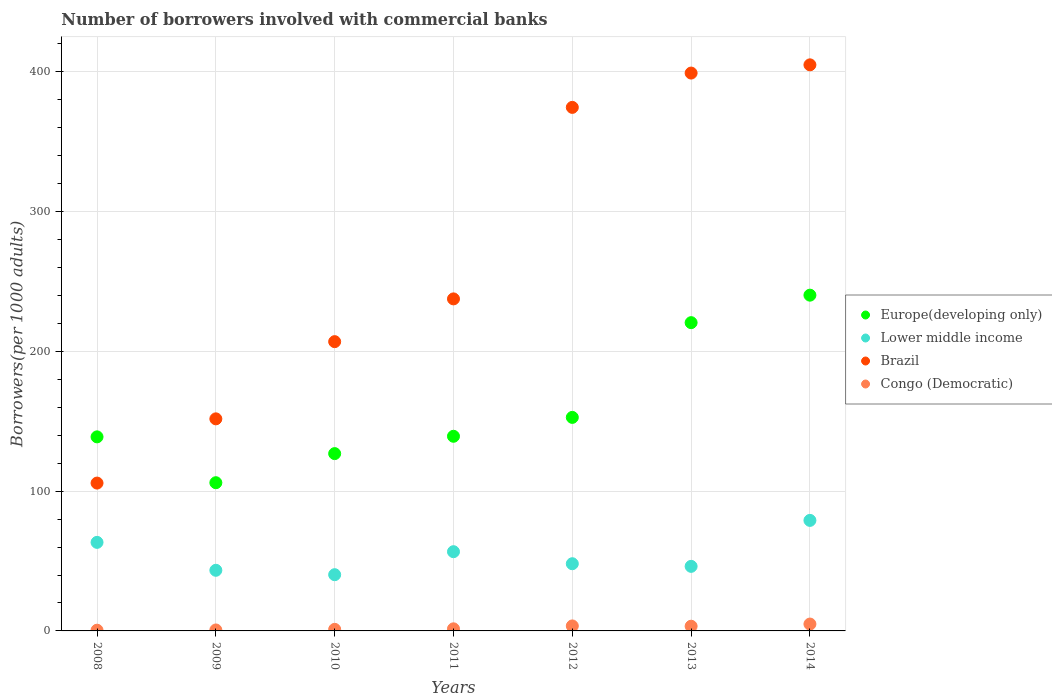Is the number of dotlines equal to the number of legend labels?
Your answer should be very brief. Yes. What is the number of borrowers involved with commercial banks in Europe(developing only) in 2010?
Offer a terse response. 126.87. Across all years, what is the maximum number of borrowers involved with commercial banks in Lower middle income?
Offer a terse response. 79.08. Across all years, what is the minimum number of borrowers involved with commercial banks in Europe(developing only)?
Provide a short and direct response. 106.05. In which year was the number of borrowers involved with commercial banks in Lower middle income minimum?
Give a very brief answer. 2010. What is the total number of borrowers involved with commercial banks in Brazil in the graph?
Provide a short and direct response. 1880.83. What is the difference between the number of borrowers involved with commercial banks in Lower middle income in 2008 and that in 2009?
Give a very brief answer. 19.98. What is the difference between the number of borrowers involved with commercial banks in Europe(developing only) in 2008 and the number of borrowers involved with commercial banks in Lower middle income in 2009?
Your answer should be very brief. 95.47. What is the average number of borrowers involved with commercial banks in Congo (Democratic) per year?
Offer a terse response. 2.24. In the year 2009, what is the difference between the number of borrowers involved with commercial banks in Lower middle income and number of borrowers involved with commercial banks in Europe(developing only)?
Offer a very short reply. -62.67. In how many years, is the number of borrowers involved with commercial banks in Europe(developing only) greater than 180?
Your response must be concise. 2. What is the ratio of the number of borrowers involved with commercial banks in Lower middle income in 2012 to that in 2014?
Your response must be concise. 0.61. Is the number of borrowers involved with commercial banks in Brazil in 2012 less than that in 2013?
Ensure brevity in your answer.  Yes. What is the difference between the highest and the second highest number of borrowers involved with commercial banks in Congo (Democratic)?
Your answer should be very brief. 1.34. What is the difference between the highest and the lowest number of borrowers involved with commercial banks in Congo (Democratic)?
Make the answer very short. 4.39. Is the sum of the number of borrowers involved with commercial banks in Congo (Democratic) in 2008 and 2012 greater than the maximum number of borrowers involved with commercial banks in Europe(developing only) across all years?
Offer a very short reply. No. Is it the case that in every year, the sum of the number of borrowers involved with commercial banks in Lower middle income and number of borrowers involved with commercial banks in Congo (Democratic)  is greater than the number of borrowers involved with commercial banks in Europe(developing only)?
Keep it short and to the point. No. Does the number of borrowers involved with commercial banks in Brazil monotonically increase over the years?
Your answer should be compact. Yes. Is the number of borrowers involved with commercial banks in Congo (Democratic) strictly less than the number of borrowers involved with commercial banks in Brazil over the years?
Provide a succinct answer. Yes. How many dotlines are there?
Offer a terse response. 4. Are the values on the major ticks of Y-axis written in scientific E-notation?
Your answer should be very brief. No. Does the graph contain any zero values?
Your response must be concise. No. Does the graph contain grids?
Provide a succinct answer. Yes. Where does the legend appear in the graph?
Your response must be concise. Center right. How many legend labels are there?
Give a very brief answer. 4. How are the legend labels stacked?
Your answer should be very brief. Vertical. What is the title of the graph?
Ensure brevity in your answer.  Number of borrowers involved with commercial banks. Does "Sao Tome and Principe" appear as one of the legend labels in the graph?
Your answer should be very brief. No. What is the label or title of the Y-axis?
Give a very brief answer. Borrowers(per 1000 adults). What is the Borrowers(per 1000 adults) of Europe(developing only) in 2008?
Give a very brief answer. 138.85. What is the Borrowers(per 1000 adults) of Lower middle income in 2008?
Offer a very short reply. 63.36. What is the Borrowers(per 1000 adults) in Brazil in 2008?
Offer a very short reply. 105.78. What is the Borrowers(per 1000 adults) of Congo (Democratic) in 2008?
Your response must be concise. 0.52. What is the Borrowers(per 1000 adults) in Europe(developing only) in 2009?
Your answer should be very brief. 106.05. What is the Borrowers(per 1000 adults) of Lower middle income in 2009?
Give a very brief answer. 43.38. What is the Borrowers(per 1000 adults) in Brazil in 2009?
Provide a short and direct response. 151.74. What is the Borrowers(per 1000 adults) of Congo (Democratic) in 2009?
Provide a succinct answer. 0.68. What is the Borrowers(per 1000 adults) in Europe(developing only) in 2010?
Provide a short and direct response. 126.87. What is the Borrowers(per 1000 adults) in Lower middle income in 2010?
Your response must be concise. 40.23. What is the Borrowers(per 1000 adults) in Brazil in 2010?
Provide a succinct answer. 206.97. What is the Borrowers(per 1000 adults) of Congo (Democratic) in 2010?
Provide a short and direct response. 1.12. What is the Borrowers(per 1000 adults) of Europe(developing only) in 2011?
Offer a terse response. 139.27. What is the Borrowers(per 1000 adults) of Lower middle income in 2011?
Ensure brevity in your answer.  56.68. What is the Borrowers(per 1000 adults) of Brazil in 2011?
Offer a very short reply. 237.57. What is the Borrowers(per 1000 adults) in Congo (Democratic) in 2011?
Your answer should be very brief. 1.5. What is the Borrowers(per 1000 adults) in Europe(developing only) in 2012?
Your answer should be very brief. 152.78. What is the Borrowers(per 1000 adults) in Lower middle income in 2012?
Give a very brief answer. 48.08. What is the Borrowers(per 1000 adults) of Brazil in 2012?
Your answer should be compact. 374.59. What is the Borrowers(per 1000 adults) in Congo (Democratic) in 2012?
Give a very brief answer. 3.57. What is the Borrowers(per 1000 adults) in Europe(developing only) in 2013?
Your answer should be very brief. 220.56. What is the Borrowers(per 1000 adults) in Lower middle income in 2013?
Ensure brevity in your answer.  46.19. What is the Borrowers(per 1000 adults) of Brazil in 2013?
Offer a very short reply. 399.14. What is the Borrowers(per 1000 adults) in Congo (Democratic) in 2013?
Make the answer very short. 3.36. What is the Borrowers(per 1000 adults) in Europe(developing only) in 2014?
Your answer should be very brief. 240.23. What is the Borrowers(per 1000 adults) in Lower middle income in 2014?
Keep it short and to the point. 79.08. What is the Borrowers(per 1000 adults) in Brazil in 2014?
Your answer should be very brief. 405.03. What is the Borrowers(per 1000 adults) in Congo (Democratic) in 2014?
Offer a terse response. 4.91. Across all years, what is the maximum Borrowers(per 1000 adults) of Europe(developing only)?
Your answer should be very brief. 240.23. Across all years, what is the maximum Borrowers(per 1000 adults) of Lower middle income?
Provide a short and direct response. 79.08. Across all years, what is the maximum Borrowers(per 1000 adults) of Brazil?
Your response must be concise. 405.03. Across all years, what is the maximum Borrowers(per 1000 adults) in Congo (Democratic)?
Your answer should be very brief. 4.91. Across all years, what is the minimum Borrowers(per 1000 adults) in Europe(developing only)?
Provide a succinct answer. 106.05. Across all years, what is the minimum Borrowers(per 1000 adults) in Lower middle income?
Offer a terse response. 40.23. Across all years, what is the minimum Borrowers(per 1000 adults) in Brazil?
Give a very brief answer. 105.78. Across all years, what is the minimum Borrowers(per 1000 adults) in Congo (Democratic)?
Your answer should be very brief. 0.52. What is the total Borrowers(per 1000 adults) in Europe(developing only) in the graph?
Offer a very short reply. 1124.6. What is the total Borrowers(per 1000 adults) in Lower middle income in the graph?
Keep it short and to the point. 377. What is the total Borrowers(per 1000 adults) in Brazil in the graph?
Give a very brief answer. 1880.83. What is the total Borrowers(per 1000 adults) in Congo (Democratic) in the graph?
Provide a short and direct response. 15.67. What is the difference between the Borrowers(per 1000 adults) of Europe(developing only) in 2008 and that in 2009?
Keep it short and to the point. 32.8. What is the difference between the Borrowers(per 1000 adults) in Lower middle income in 2008 and that in 2009?
Ensure brevity in your answer.  19.98. What is the difference between the Borrowers(per 1000 adults) in Brazil in 2008 and that in 2009?
Keep it short and to the point. -45.96. What is the difference between the Borrowers(per 1000 adults) in Congo (Democratic) in 2008 and that in 2009?
Offer a very short reply. -0.16. What is the difference between the Borrowers(per 1000 adults) of Europe(developing only) in 2008 and that in 2010?
Provide a short and direct response. 11.98. What is the difference between the Borrowers(per 1000 adults) in Lower middle income in 2008 and that in 2010?
Your answer should be very brief. 23.13. What is the difference between the Borrowers(per 1000 adults) of Brazil in 2008 and that in 2010?
Your response must be concise. -101.2. What is the difference between the Borrowers(per 1000 adults) in Congo (Democratic) in 2008 and that in 2010?
Keep it short and to the point. -0.61. What is the difference between the Borrowers(per 1000 adults) of Europe(developing only) in 2008 and that in 2011?
Provide a succinct answer. -0.42. What is the difference between the Borrowers(per 1000 adults) of Lower middle income in 2008 and that in 2011?
Your answer should be very brief. 6.67. What is the difference between the Borrowers(per 1000 adults) of Brazil in 2008 and that in 2011?
Offer a very short reply. -131.79. What is the difference between the Borrowers(per 1000 adults) of Congo (Democratic) in 2008 and that in 2011?
Your answer should be compact. -0.98. What is the difference between the Borrowers(per 1000 adults) of Europe(developing only) in 2008 and that in 2012?
Your answer should be compact. -13.93. What is the difference between the Borrowers(per 1000 adults) in Lower middle income in 2008 and that in 2012?
Keep it short and to the point. 15.28. What is the difference between the Borrowers(per 1000 adults) of Brazil in 2008 and that in 2012?
Offer a terse response. -268.82. What is the difference between the Borrowers(per 1000 adults) in Congo (Democratic) in 2008 and that in 2012?
Give a very brief answer. -3.05. What is the difference between the Borrowers(per 1000 adults) in Europe(developing only) in 2008 and that in 2013?
Make the answer very short. -81.71. What is the difference between the Borrowers(per 1000 adults) in Lower middle income in 2008 and that in 2013?
Make the answer very short. 17.17. What is the difference between the Borrowers(per 1000 adults) in Brazil in 2008 and that in 2013?
Your answer should be compact. -293.36. What is the difference between the Borrowers(per 1000 adults) of Congo (Democratic) in 2008 and that in 2013?
Ensure brevity in your answer.  -2.84. What is the difference between the Borrowers(per 1000 adults) in Europe(developing only) in 2008 and that in 2014?
Provide a short and direct response. -101.38. What is the difference between the Borrowers(per 1000 adults) in Lower middle income in 2008 and that in 2014?
Ensure brevity in your answer.  -15.72. What is the difference between the Borrowers(per 1000 adults) in Brazil in 2008 and that in 2014?
Your answer should be compact. -299.25. What is the difference between the Borrowers(per 1000 adults) of Congo (Democratic) in 2008 and that in 2014?
Provide a short and direct response. -4.39. What is the difference between the Borrowers(per 1000 adults) of Europe(developing only) in 2009 and that in 2010?
Keep it short and to the point. -20.82. What is the difference between the Borrowers(per 1000 adults) in Lower middle income in 2009 and that in 2010?
Provide a succinct answer. 3.15. What is the difference between the Borrowers(per 1000 adults) of Brazil in 2009 and that in 2010?
Your answer should be very brief. -55.23. What is the difference between the Borrowers(per 1000 adults) of Congo (Democratic) in 2009 and that in 2010?
Offer a very short reply. -0.44. What is the difference between the Borrowers(per 1000 adults) in Europe(developing only) in 2009 and that in 2011?
Provide a short and direct response. -33.22. What is the difference between the Borrowers(per 1000 adults) of Lower middle income in 2009 and that in 2011?
Keep it short and to the point. -13.31. What is the difference between the Borrowers(per 1000 adults) of Brazil in 2009 and that in 2011?
Ensure brevity in your answer.  -85.83. What is the difference between the Borrowers(per 1000 adults) of Congo (Democratic) in 2009 and that in 2011?
Provide a short and direct response. -0.82. What is the difference between the Borrowers(per 1000 adults) in Europe(developing only) in 2009 and that in 2012?
Keep it short and to the point. -46.73. What is the difference between the Borrowers(per 1000 adults) of Lower middle income in 2009 and that in 2012?
Your answer should be very brief. -4.7. What is the difference between the Borrowers(per 1000 adults) in Brazil in 2009 and that in 2012?
Keep it short and to the point. -222.85. What is the difference between the Borrowers(per 1000 adults) in Congo (Democratic) in 2009 and that in 2012?
Provide a succinct answer. -2.89. What is the difference between the Borrowers(per 1000 adults) of Europe(developing only) in 2009 and that in 2013?
Keep it short and to the point. -114.52. What is the difference between the Borrowers(per 1000 adults) of Lower middle income in 2009 and that in 2013?
Your answer should be very brief. -2.81. What is the difference between the Borrowers(per 1000 adults) in Brazil in 2009 and that in 2013?
Your response must be concise. -247.4. What is the difference between the Borrowers(per 1000 adults) of Congo (Democratic) in 2009 and that in 2013?
Provide a succinct answer. -2.68. What is the difference between the Borrowers(per 1000 adults) of Europe(developing only) in 2009 and that in 2014?
Offer a very short reply. -134.19. What is the difference between the Borrowers(per 1000 adults) in Lower middle income in 2009 and that in 2014?
Offer a very short reply. -35.7. What is the difference between the Borrowers(per 1000 adults) in Brazil in 2009 and that in 2014?
Keep it short and to the point. -253.29. What is the difference between the Borrowers(per 1000 adults) in Congo (Democratic) in 2009 and that in 2014?
Ensure brevity in your answer.  -4.23. What is the difference between the Borrowers(per 1000 adults) of Europe(developing only) in 2010 and that in 2011?
Offer a terse response. -12.4. What is the difference between the Borrowers(per 1000 adults) in Lower middle income in 2010 and that in 2011?
Offer a terse response. -16.45. What is the difference between the Borrowers(per 1000 adults) in Brazil in 2010 and that in 2011?
Make the answer very short. -30.59. What is the difference between the Borrowers(per 1000 adults) of Congo (Democratic) in 2010 and that in 2011?
Ensure brevity in your answer.  -0.38. What is the difference between the Borrowers(per 1000 adults) of Europe(developing only) in 2010 and that in 2012?
Your answer should be compact. -25.91. What is the difference between the Borrowers(per 1000 adults) of Lower middle income in 2010 and that in 2012?
Your answer should be very brief. -7.85. What is the difference between the Borrowers(per 1000 adults) of Brazil in 2010 and that in 2012?
Your answer should be compact. -167.62. What is the difference between the Borrowers(per 1000 adults) of Congo (Democratic) in 2010 and that in 2012?
Provide a short and direct response. -2.45. What is the difference between the Borrowers(per 1000 adults) in Europe(developing only) in 2010 and that in 2013?
Your answer should be very brief. -93.7. What is the difference between the Borrowers(per 1000 adults) in Lower middle income in 2010 and that in 2013?
Ensure brevity in your answer.  -5.96. What is the difference between the Borrowers(per 1000 adults) in Brazil in 2010 and that in 2013?
Your answer should be very brief. -192.17. What is the difference between the Borrowers(per 1000 adults) of Congo (Democratic) in 2010 and that in 2013?
Give a very brief answer. -2.24. What is the difference between the Borrowers(per 1000 adults) of Europe(developing only) in 2010 and that in 2014?
Provide a short and direct response. -113.37. What is the difference between the Borrowers(per 1000 adults) of Lower middle income in 2010 and that in 2014?
Keep it short and to the point. -38.85. What is the difference between the Borrowers(per 1000 adults) in Brazil in 2010 and that in 2014?
Ensure brevity in your answer.  -198.06. What is the difference between the Borrowers(per 1000 adults) of Congo (Democratic) in 2010 and that in 2014?
Give a very brief answer. -3.79. What is the difference between the Borrowers(per 1000 adults) of Europe(developing only) in 2011 and that in 2012?
Ensure brevity in your answer.  -13.51. What is the difference between the Borrowers(per 1000 adults) of Lower middle income in 2011 and that in 2012?
Provide a short and direct response. 8.61. What is the difference between the Borrowers(per 1000 adults) in Brazil in 2011 and that in 2012?
Give a very brief answer. -137.03. What is the difference between the Borrowers(per 1000 adults) of Congo (Democratic) in 2011 and that in 2012?
Give a very brief answer. -2.07. What is the difference between the Borrowers(per 1000 adults) of Europe(developing only) in 2011 and that in 2013?
Provide a succinct answer. -81.3. What is the difference between the Borrowers(per 1000 adults) in Lower middle income in 2011 and that in 2013?
Make the answer very short. 10.49. What is the difference between the Borrowers(per 1000 adults) in Brazil in 2011 and that in 2013?
Keep it short and to the point. -161.57. What is the difference between the Borrowers(per 1000 adults) in Congo (Democratic) in 2011 and that in 2013?
Keep it short and to the point. -1.86. What is the difference between the Borrowers(per 1000 adults) in Europe(developing only) in 2011 and that in 2014?
Keep it short and to the point. -100.97. What is the difference between the Borrowers(per 1000 adults) in Lower middle income in 2011 and that in 2014?
Give a very brief answer. -22.4. What is the difference between the Borrowers(per 1000 adults) in Brazil in 2011 and that in 2014?
Provide a succinct answer. -167.46. What is the difference between the Borrowers(per 1000 adults) of Congo (Democratic) in 2011 and that in 2014?
Ensure brevity in your answer.  -3.41. What is the difference between the Borrowers(per 1000 adults) of Europe(developing only) in 2012 and that in 2013?
Keep it short and to the point. -67.78. What is the difference between the Borrowers(per 1000 adults) of Lower middle income in 2012 and that in 2013?
Your answer should be compact. 1.89. What is the difference between the Borrowers(per 1000 adults) of Brazil in 2012 and that in 2013?
Offer a terse response. -24.55. What is the difference between the Borrowers(per 1000 adults) of Congo (Democratic) in 2012 and that in 2013?
Give a very brief answer. 0.21. What is the difference between the Borrowers(per 1000 adults) of Europe(developing only) in 2012 and that in 2014?
Ensure brevity in your answer.  -87.45. What is the difference between the Borrowers(per 1000 adults) in Lower middle income in 2012 and that in 2014?
Make the answer very short. -31. What is the difference between the Borrowers(per 1000 adults) in Brazil in 2012 and that in 2014?
Provide a succinct answer. -30.44. What is the difference between the Borrowers(per 1000 adults) of Congo (Democratic) in 2012 and that in 2014?
Your answer should be compact. -1.34. What is the difference between the Borrowers(per 1000 adults) of Europe(developing only) in 2013 and that in 2014?
Offer a very short reply. -19.67. What is the difference between the Borrowers(per 1000 adults) in Lower middle income in 2013 and that in 2014?
Give a very brief answer. -32.89. What is the difference between the Borrowers(per 1000 adults) of Brazil in 2013 and that in 2014?
Offer a terse response. -5.89. What is the difference between the Borrowers(per 1000 adults) of Congo (Democratic) in 2013 and that in 2014?
Offer a very short reply. -1.55. What is the difference between the Borrowers(per 1000 adults) in Europe(developing only) in 2008 and the Borrowers(per 1000 adults) in Lower middle income in 2009?
Make the answer very short. 95.47. What is the difference between the Borrowers(per 1000 adults) in Europe(developing only) in 2008 and the Borrowers(per 1000 adults) in Brazil in 2009?
Provide a succinct answer. -12.89. What is the difference between the Borrowers(per 1000 adults) in Europe(developing only) in 2008 and the Borrowers(per 1000 adults) in Congo (Democratic) in 2009?
Ensure brevity in your answer.  138.17. What is the difference between the Borrowers(per 1000 adults) of Lower middle income in 2008 and the Borrowers(per 1000 adults) of Brazil in 2009?
Provide a succinct answer. -88.38. What is the difference between the Borrowers(per 1000 adults) in Lower middle income in 2008 and the Borrowers(per 1000 adults) in Congo (Democratic) in 2009?
Your answer should be very brief. 62.67. What is the difference between the Borrowers(per 1000 adults) in Brazil in 2008 and the Borrowers(per 1000 adults) in Congo (Democratic) in 2009?
Give a very brief answer. 105.09. What is the difference between the Borrowers(per 1000 adults) of Europe(developing only) in 2008 and the Borrowers(per 1000 adults) of Lower middle income in 2010?
Your answer should be very brief. 98.62. What is the difference between the Borrowers(per 1000 adults) of Europe(developing only) in 2008 and the Borrowers(per 1000 adults) of Brazil in 2010?
Make the answer very short. -68.13. What is the difference between the Borrowers(per 1000 adults) in Europe(developing only) in 2008 and the Borrowers(per 1000 adults) in Congo (Democratic) in 2010?
Make the answer very short. 137.72. What is the difference between the Borrowers(per 1000 adults) in Lower middle income in 2008 and the Borrowers(per 1000 adults) in Brazil in 2010?
Your response must be concise. -143.62. What is the difference between the Borrowers(per 1000 adults) in Lower middle income in 2008 and the Borrowers(per 1000 adults) in Congo (Democratic) in 2010?
Make the answer very short. 62.23. What is the difference between the Borrowers(per 1000 adults) in Brazil in 2008 and the Borrowers(per 1000 adults) in Congo (Democratic) in 2010?
Provide a short and direct response. 104.65. What is the difference between the Borrowers(per 1000 adults) of Europe(developing only) in 2008 and the Borrowers(per 1000 adults) of Lower middle income in 2011?
Offer a very short reply. 82.16. What is the difference between the Borrowers(per 1000 adults) of Europe(developing only) in 2008 and the Borrowers(per 1000 adults) of Brazil in 2011?
Make the answer very short. -98.72. What is the difference between the Borrowers(per 1000 adults) of Europe(developing only) in 2008 and the Borrowers(per 1000 adults) of Congo (Democratic) in 2011?
Ensure brevity in your answer.  137.35. What is the difference between the Borrowers(per 1000 adults) of Lower middle income in 2008 and the Borrowers(per 1000 adults) of Brazil in 2011?
Your answer should be very brief. -174.21. What is the difference between the Borrowers(per 1000 adults) of Lower middle income in 2008 and the Borrowers(per 1000 adults) of Congo (Democratic) in 2011?
Provide a succinct answer. 61.86. What is the difference between the Borrowers(per 1000 adults) of Brazil in 2008 and the Borrowers(per 1000 adults) of Congo (Democratic) in 2011?
Provide a succinct answer. 104.28. What is the difference between the Borrowers(per 1000 adults) in Europe(developing only) in 2008 and the Borrowers(per 1000 adults) in Lower middle income in 2012?
Make the answer very short. 90.77. What is the difference between the Borrowers(per 1000 adults) in Europe(developing only) in 2008 and the Borrowers(per 1000 adults) in Brazil in 2012?
Offer a very short reply. -235.75. What is the difference between the Borrowers(per 1000 adults) in Europe(developing only) in 2008 and the Borrowers(per 1000 adults) in Congo (Democratic) in 2012?
Your response must be concise. 135.28. What is the difference between the Borrowers(per 1000 adults) in Lower middle income in 2008 and the Borrowers(per 1000 adults) in Brazil in 2012?
Keep it short and to the point. -311.24. What is the difference between the Borrowers(per 1000 adults) of Lower middle income in 2008 and the Borrowers(per 1000 adults) of Congo (Democratic) in 2012?
Your answer should be very brief. 59.79. What is the difference between the Borrowers(per 1000 adults) in Brazil in 2008 and the Borrowers(per 1000 adults) in Congo (Democratic) in 2012?
Give a very brief answer. 102.21. What is the difference between the Borrowers(per 1000 adults) in Europe(developing only) in 2008 and the Borrowers(per 1000 adults) in Lower middle income in 2013?
Your answer should be compact. 92.66. What is the difference between the Borrowers(per 1000 adults) in Europe(developing only) in 2008 and the Borrowers(per 1000 adults) in Brazil in 2013?
Keep it short and to the point. -260.29. What is the difference between the Borrowers(per 1000 adults) of Europe(developing only) in 2008 and the Borrowers(per 1000 adults) of Congo (Democratic) in 2013?
Give a very brief answer. 135.49. What is the difference between the Borrowers(per 1000 adults) in Lower middle income in 2008 and the Borrowers(per 1000 adults) in Brazil in 2013?
Your answer should be very brief. -335.79. What is the difference between the Borrowers(per 1000 adults) of Lower middle income in 2008 and the Borrowers(per 1000 adults) of Congo (Democratic) in 2013?
Ensure brevity in your answer.  60. What is the difference between the Borrowers(per 1000 adults) in Brazil in 2008 and the Borrowers(per 1000 adults) in Congo (Democratic) in 2013?
Ensure brevity in your answer.  102.42. What is the difference between the Borrowers(per 1000 adults) of Europe(developing only) in 2008 and the Borrowers(per 1000 adults) of Lower middle income in 2014?
Give a very brief answer. 59.77. What is the difference between the Borrowers(per 1000 adults) of Europe(developing only) in 2008 and the Borrowers(per 1000 adults) of Brazil in 2014?
Offer a very short reply. -266.18. What is the difference between the Borrowers(per 1000 adults) of Europe(developing only) in 2008 and the Borrowers(per 1000 adults) of Congo (Democratic) in 2014?
Keep it short and to the point. 133.93. What is the difference between the Borrowers(per 1000 adults) in Lower middle income in 2008 and the Borrowers(per 1000 adults) in Brazil in 2014?
Your answer should be compact. -341.67. What is the difference between the Borrowers(per 1000 adults) in Lower middle income in 2008 and the Borrowers(per 1000 adults) in Congo (Democratic) in 2014?
Offer a very short reply. 58.44. What is the difference between the Borrowers(per 1000 adults) in Brazil in 2008 and the Borrowers(per 1000 adults) in Congo (Democratic) in 2014?
Give a very brief answer. 100.86. What is the difference between the Borrowers(per 1000 adults) of Europe(developing only) in 2009 and the Borrowers(per 1000 adults) of Lower middle income in 2010?
Your response must be concise. 65.82. What is the difference between the Borrowers(per 1000 adults) of Europe(developing only) in 2009 and the Borrowers(per 1000 adults) of Brazil in 2010?
Make the answer very short. -100.93. What is the difference between the Borrowers(per 1000 adults) in Europe(developing only) in 2009 and the Borrowers(per 1000 adults) in Congo (Democratic) in 2010?
Your answer should be very brief. 104.92. What is the difference between the Borrowers(per 1000 adults) in Lower middle income in 2009 and the Borrowers(per 1000 adults) in Brazil in 2010?
Keep it short and to the point. -163.6. What is the difference between the Borrowers(per 1000 adults) of Lower middle income in 2009 and the Borrowers(per 1000 adults) of Congo (Democratic) in 2010?
Give a very brief answer. 42.25. What is the difference between the Borrowers(per 1000 adults) of Brazil in 2009 and the Borrowers(per 1000 adults) of Congo (Democratic) in 2010?
Keep it short and to the point. 150.62. What is the difference between the Borrowers(per 1000 adults) in Europe(developing only) in 2009 and the Borrowers(per 1000 adults) in Lower middle income in 2011?
Make the answer very short. 49.36. What is the difference between the Borrowers(per 1000 adults) of Europe(developing only) in 2009 and the Borrowers(per 1000 adults) of Brazil in 2011?
Your answer should be compact. -131.52. What is the difference between the Borrowers(per 1000 adults) of Europe(developing only) in 2009 and the Borrowers(per 1000 adults) of Congo (Democratic) in 2011?
Provide a short and direct response. 104.55. What is the difference between the Borrowers(per 1000 adults) of Lower middle income in 2009 and the Borrowers(per 1000 adults) of Brazil in 2011?
Your response must be concise. -194.19. What is the difference between the Borrowers(per 1000 adults) of Lower middle income in 2009 and the Borrowers(per 1000 adults) of Congo (Democratic) in 2011?
Keep it short and to the point. 41.88. What is the difference between the Borrowers(per 1000 adults) of Brazil in 2009 and the Borrowers(per 1000 adults) of Congo (Democratic) in 2011?
Your answer should be compact. 150.24. What is the difference between the Borrowers(per 1000 adults) in Europe(developing only) in 2009 and the Borrowers(per 1000 adults) in Lower middle income in 2012?
Provide a short and direct response. 57.97. What is the difference between the Borrowers(per 1000 adults) of Europe(developing only) in 2009 and the Borrowers(per 1000 adults) of Brazil in 2012?
Ensure brevity in your answer.  -268.55. What is the difference between the Borrowers(per 1000 adults) of Europe(developing only) in 2009 and the Borrowers(per 1000 adults) of Congo (Democratic) in 2012?
Your answer should be compact. 102.48. What is the difference between the Borrowers(per 1000 adults) of Lower middle income in 2009 and the Borrowers(per 1000 adults) of Brazil in 2012?
Offer a terse response. -331.22. What is the difference between the Borrowers(per 1000 adults) of Lower middle income in 2009 and the Borrowers(per 1000 adults) of Congo (Democratic) in 2012?
Provide a succinct answer. 39.81. What is the difference between the Borrowers(per 1000 adults) of Brazil in 2009 and the Borrowers(per 1000 adults) of Congo (Democratic) in 2012?
Keep it short and to the point. 148.17. What is the difference between the Borrowers(per 1000 adults) of Europe(developing only) in 2009 and the Borrowers(per 1000 adults) of Lower middle income in 2013?
Provide a short and direct response. 59.85. What is the difference between the Borrowers(per 1000 adults) in Europe(developing only) in 2009 and the Borrowers(per 1000 adults) in Brazil in 2013?
Provide a succinct answer. -293.1. What is the difference between the Borrowers(per 1000 adults) of Europe(developing only) in 2009 and the Borrowers(per 1000 adults) of Congo (Democratic) in 2013?
Make the answer very short. 102.68. What is the difference between the Borrowers(per 1000 adults) in Lower middle income in 2009 and the Borrowers(per 1000 adults) in Brazil in 2013?
Ensure brevity in your answer.  -355.77. What is the difference between the Borrowers(per 1000 adults) in Lower middle income in 2009 and the Borrowers(per 1000 adults) in Congo (Democratic) in 2013?
Offer a terse response. 40.02. What is the difference between the Borrowers(per 1000 adults) of Brazil in 2009 and the Borrowers(per 1000 adults) of Congo (Democratic) in 2013?
Your response must be concise. 148.38. What is the difference between the Borrowers(per 1000 adults) of Europe(developing only) in 2009 and the Borrowers(per 1000 adults) of Lower middle income in 2014?
Your response must be concise. 26.96. What is the difference between the Borrowers(per 1000 adults) of Europe(developing only) in 2009 and the Borrowers(per 1000 adults) of Brazil in 2014?
Your response must be concise. -298.98. What is the difference between the Borrowers(per 1000 adults) in Europe(developing only) in 2009 and the Borrowers(per 1000 adults) in Congo (Democratic) in 2014?
Your answer should be very brief. 101.13. What is the difference between the Borrowers(per 1000 adults) of Lower middle income in 2009 and the Borrowers(per 1000 adults) of Brazil in 2014?
Make the answer very short. -361.65. What is the difference between the Borrowers(per 1000 adults) of Lower middle income in 2009 and the Borrowers(per 1000 adults) of Congo (Democratic) in 2014?
Your answer should be compact. 38.46. What is the difference between the Borrowers(per 1000 adults) in Brazil in 2009 and the Borrowers(per 1000 adults) in Congo (Democratic) in 2014?
Make the answer very short. 146.83. What is the difference between the Borrowers(per 1000 adults) in Europe(developing only) in 2010 and the Borrowers(per 1000 adults) in Lower middle income in 2011?
Provide a succinct answer. 70.18. What is the difference between the Borrowers(per 1000 adults) in Europe(developing only) in 2010 and the Borrowers(per 1000 adults) in Brazil in 2011?
Give a very brief answer. -110.7. What is the difference between the Borrowers(per 1000 adults) of Europe(developing only) in 2010 and the Borrowers(per 1000 adults) of Congo (Democratic) in 2011?
Your answer should be compact. 125.37. What is the difference between the Borrowers(per 1000 adults) of Lower middle income in 2010 and the Borrowers(per 1000 adults) of Brazil in 2011?
Make the answer very short. -197.34. What is the difference between the Borrowers(per 1000 adults) of Lower middle income in 2010 and the Borrowers(per 1000 adults) of Congo (Democratic) in 2011?
Your answer should be very brief. 38.73. What is the difference between the Borrowers(per 1000 adults) of Brazil in 2010 and the Borrowers(per 1000 adults) of Congo (Democratic) in 2011?
Give a very brief answer. 205.47. What is the difference between the Borrowers(per 1000 adults) in Europe(developing only) in 2010 and the Borrowers(per 1000 adults) in Lower middle income in 2012?
Ensure brevity in your answer.  78.79. What is the difference between the Borrowers(per 1000 adults) of Europe(developing only) in 2010 and the Borrowers(per 1000 adults) of Brazil in 2012?
Keep it short and to the point. -247.73. What is the difference between the Borrowers(per 1000 adults) of Europe(developing only) in 2010 and the Borrowers(per 1000 adults) of Congo (Democratic) in 2012?
Your response must be concise. 123.3. What is the difference between the Borrowers(per 1000 adults) in Lower middle income in 2010 and the Borrowers(per 1000 adults) in Brazil in 2012?
Give a very brief answer. -334.36. What is the difference between the Borrowers(per 1000 adults) of Lower middle income in 2010 and the Borrowers(per 1000 adults) of Congo (Democratic) in 2012?
Offer a terse response. 36.66. What is the difference between the Borrowers(per 1000 adults) in Brazil in 2010 and the Borrowers(per 1000 adults) in Congo (Democratic) in 2012?
Keep it short and to the point. 203.4. What is the difference between the Borrowers(per 1000 adults) in Europe(developing only) in 2010 and the Borrowers(per 1000 adults) in Lower middle income in 2013?
Ensure brevity in your answer.  80.67. What is the difference between the Borrowers(per 1000 adults) in Europe(developing only) in 2010 and the Borrowers(per 1000 adults) in Brazil in 2013?
Give a very brief answer. -272.28. What is the difference between the Borrowers(per 1000 adults) in Europe(developing only) in 2010 and the Borrowers(per 1000 adults) in Congo (Democratic) in 2013?
Give a very brief answer. 123.51. What is the difference between the Borrowers(per 1000 adults) in Lower middle income in 2010 and the Borrowers(per 1000 adults) in Brazil in 2013?
Offer a terse response. -358.91. What is the difference between the Borrowers(per 1000 adults) in Lower middle income in 2010 and the Borrowers(per 1000 adults) in Congo (Democratic) in 2013?
Give a very brief answer. 36.87. What is the difference between the Borrowers(per 1000 adults) of Brazil in 2010 and the Borrowers(per 1000 adults) of Congo (Democratic) in 2013?
Offer a terse response. 203.61. What is the difference between the Borrowers(per 1000 adults) in Europe(developing only) in 2010 and the Borrowers(per 1000 adults) in Lower middle income in 2014?
Your answer should be compact. 47.79. What is the difference between the Borrowers(per 1000 adults) of Europe(developing only) in 2010 and the Borrowers(per 1000 adults) of Brazil in 2014?
Offer a very short reply. -278.16. What is the difference between the Borrowers(per 1000 adults) of Europe(developing only) in 2010 and the Borrowers(per 1000 adults) of Congo (Democratic) in 2014?
Ensure brevity in your answer.  121.95. What is the difference between the Borrowers(per 1000 adults) of Lower middle income in 2010 and the Borrowers(per 1000 adults) of Brazil in 2014?
Offer a very short reply. -364.8. What is the difference between the Borrowers(per 1000 adults) in Lower middle income in 2010 and the Borrowers(per 1000 adults) in Congo (Democratic) in 2014?
Offer a terse response. 35.32. What is the difference between the Borrowers(per 1000 adults) of Brazil in 2010 and the Borrowers(per 1000 adults) of Congo (Democratic) in 2014?
Provide a succinct answer. 202.06. What is the difference between the Borrowers(per 1000 adults) in Europe(developing only) in 2011 and the Borrowers(per 1000 adults) in Lower middle income in 2012?
Provide a succinct answer. 91.19. What is the difference between the Borrowers(per 1000 adults) in Europe(developing only) in 2011 and the Borrowers(per 1000 adults) in Brazil in 2012?
Give a very brief answer. -235.33. What is the difference between the Borrowers(per 1000 adults) in Europe(developing only) in 2011 and the Borrowers(per 1000 adults) in Congo (Democratic) in 2012?
Give a very brief answer. 135.7. What is the difference between the Borrowers(per 1000 adults) of Lower middle income in 2011 and the Borrowers(per 1000 adults) of Brazil in 2012?
Make the answer very short. -317.91. What is the difference between the Borrowers(per 1000 adults) in Lower middle income in 2011 and the Borrowers(per 1000 adults) in Congo (Democratic) in 2012?
Offer a very short reply. 53.11. What is the difference between the Borrowers(per 1000 adults) in Brazil in 2011 and the Borrowers(per 1000 adults) in Congo (Democratic) in 2012?
Your answer should be very brief. 234. What is the difference between the Borrowers(per 1000 adults) in Europe(developing only) in 2011 and the Borrowers(per 1000 adults) in Lower middle income in 2013?
Provide a succinct answer. 93.07. What is the difference between the Borrowers(per 1000 adults) of Europe(developing only) in 2011 and the Borrowers(per 1000 adults) of Brazil in 2013?
Ensure brevity in your answer.  -259.88. What is the difference between the Borrowers(per 1000 adults) of Europe(developing only) in 2011 and the Borrowers(per 1000 adults) of Congo (Democratic) in 2013?
Your answer should be compact. 135.9. What is the difference between the Borrowers(per 1000 adults) of Lower middle income in 2011 and the Borrowers(per 1000 adults) of Brazil in 2013?
Offer a terse response. -342.46. What is the difference between the Borrowers(per 1000 adults) in Lower middle income in 2011 and the Borrowers(per 1000 adults) in Congo (Democratic) in 2013?
Your response must be concise. 53.32. What is the difference between the Borrowers(per 1000 adults) of Brazil in 2011 and the Borrowers(per 1000 adults) of Congo (Democratic) in 2013?
Offer a terse response. 234.21. What is the difference between the Borrowers(per 1000 adults) in Europe(developing only) in 2011 and the Borrowers(per 1000 adults) in Lower middle income in 2014?
Keep it short and to the point. 60.19. What is the difference between the Borrowers(per 1000 adults) of Europe(developing only) in 2011 and the Borrowers(per 1000 adults) of Brazil in 2014?
Keep it short and to the point. -265.76. What is the difference between the Borrowers(per 1000 adults) of Europe(developing only) in 2011 and the Borrowers(per 1000 adults) of Congo (Democratic) in 2014?
Your answer should be compact. 134.35. What is the difference between the Borrowers(per 1000 adults) of Lower middle income in 2011 and the Borrowers(per 1000 adults) of Brazil in 2014?
Your response must be concise. -348.35. What is the difference between the Borrowers(per 1000 adults) in Lower middle income in 2011 and the Borrowers(per 1000 adults) in Congo (Democratic) in 2014?
Keep it short and to the point. 51.77. What is the difference between the Borrowers(per 1000 adults) of Brazil in 2011 and the Borrowers(per 1000 adults) of Congo (Democratic) in 2014?
Offer a very short reply. 232.66. What is the difference between the Borrowers(per 1000 adults) in Europe(developing only) in 2012 and the Borrowers(per 1000 adults) in Lower middle income in 2013?
Make the answer very short. 106.59. What is the difference between the Borrowers(per 1000 adults) in Europe(developing only) in 2012 and the Borrowers(per 1000 adults) in Brazil in 2013?
Ensure brevity in your answer.  -246.36. What is the difference between the Borrowers(per 1000 adults) in Europe(developing only) in 2012 and the Borrowers(per 1000 adults) in Congo (Democratic) in 2013?
Your answer should be very brief. 149.42. What is the difference between the Borrowers(per 1000 adults) in Lower middle income in 2012 and the Borrowers(per 1000 adults) in Brazil in 2013?
Provide a short and direct response. -351.06. What is the difference between the Borrowers(per 1000 adults) of Lower middle income in 2012 and the Borrowers(per 1000 adults) of Congo (Democratic) in 2013?
Provide a short and direct response. 44.72. What is the difference between the Borrowers(per 1000 adults) of Brazil in 2012 and the Borrowers(per 1000 adults) of Congo (Democratic) in 2013?
Give a very brief answer. 371.23. What is the difference between the Borrowers(per 1000 adults) in Europe(developing only) in 2012 and the Borrowers(per 1000 adults) in Lower middle income in 2014?
Give a very brief answer. 73.7. What is the difference between the Borrowers(per 1000 adults) of Europe(developing only) in 2012 and the Borrowers(per 1000 adults) of Brazil in 2014?
Offer a terse response. -252.25. What is the difference between the Borrowers(per 1000 adults) of Europe(developing only) in 2012 and the Borrowers(per 1000 adults) of Congo (Democratic) in 2014?
Offer a very short reply. 147.87. What is the difference between the Borrowers(per 1000 adults) in Lower middle income in 2012 and the Borrowers(per 1000 adults) in Brazil in 2014?
Keep it short and to the point. -356.95. What is the difference between the Borrowers(per 1000 adults) in Lower middle income in 2012 and the Borrowers(per 1000 adults) in Congo (Democratic) in 2014?
Give a very brief answer. 43.16. What is the difference between the Borrowers(per 1000 adults) in Brazil in 2012 and the Borrowers(per 1000 adults) in Congo (Democratic) in 2014?
Provide a short and direct response. 369.68. What is the difference between the Borrowers(per 1000 adults) in Europe(developing only) in 2013 and the Borrowers(per 1000 adults) in Lower middle income in 2014?
Provide a short and direct response. 141.48. What is the difference between the Borrowers(per 1000 adults) of Europe(developing only) in 2013 and the Borrowers(per 1000 adults) of Brazil in 2014?
Offer a very short reply. -184.47. What is the difference between the Borrowers(per 1000 adults) of Europe(developing only) in 2013 and the Borrowers(per 1000 adults) of Congo (Democratic) in 2014?
Your answer should be compact. 215.65. What is the difference between the Borrowers(per 1000 adults) in Lower middle income in 2013 and the Borrowers(per 1000 adults) in Brazil in 2014?
Your response must be concise. -358.84. What is the difference between the Borrowers(per 1000 adults) of Lower middle income in 2013 and the Borrowers(per 1000 adults) of Congo (Democratic) in 2014?
Your response must be concise. 41.28. What is the difference between the Borrowers(per 1000 adults) of Brazil in 2013 and the Borrowers(per 1000 adults) of Congo (Democratic) in 2014?
Offer a terse response. 394.23. What is the average Borrowers(per 1000 adults) of Europe(developing only) per year?
Provide a succinct answer. 160.66. What is the average Borrowers(per 1000 adults) of Lower middle income per year?
Your answer should be very brief. 53.86. What is the average Borrowers(per 1000 adults) in Brazil per year?
Keep it short and to the point. 268.69. What is the average Borrowers(per 1000 adults) in Congo (Democratic) per year?
Ensure brevity in your answer.  2.24. In the year 2008, what is the difference between the Borrowers(per 1000 adults) in Europe(developing only) and Borrowers(per 1000 adults) in Lower middle income?
Provide a short and direct response. 75.49. In the year 2008, what is the difference between the Borrowers(per 1000 adults) in Europe(developing only) and Borrowers(per 1000 adults) in Brazil?
Offer a very short reply. 33.07. In the year 2008, what is the difference between the Borrowers(per 1000 adults) in Europe(developing only) and Borrowers(per 1000 adults) in Congo (Democratic)?
Your response must be concise. 138.33. In the year 2008, what is the difference between the Borrowers(per 1000 adults) of Lower middle income and Borrowers(per 1000 adults) of Brazil?
Ensure brevity in your answer.  -42.42. In the year 2008, what is the difference between the Borrowers(per 1000 adults) in Lower middle income and Borrowers(per 1000 adults) in Congo (Democratic)?
Keep it short and to the point. 62.84. In the year 2008, what is the difference between the Borrowers(per 1000 adults) of Brazil and Borrowers(per 1000 adults) of Congo (Democratic)?
Give a very brief answer. 105.26. In the year 2009, what is the difference between the Borrowers(per 1000 adults) of Europe(developing only) and Borrowers(per 1000 adults) of Lower middle income?
Make the answer very short. 62.67. In the year 2009, what is the difference between the Borrowers(per 1000 adults) in Europe(developing only) and Borrowers(per 1000 adults) in Brazil?
Provide a succinct answer. -45.69. In the year 2009, what is the difference between the Borrowers(per 1000 adults) of Europe(developing only) and Borrowers(per 1000 adults) of Congo (Democratic)?
Your answer should be compact. 105.36. In the year 2009, what is the difference between the Borrowers(per 1000 adults) of Lower middle income and Borrowers(per 1000 adults) of Brazil?
Ensure brevity in your answer.  -108.36. In the year 2009, what is the difference between the Borrowers(per 1000 adults) in Lower middle income and Borrowers(per 1000 adults) in Congo (Democratic)?
Offer a very short reply. 42.69. In the year 2009, what is the difference between the Borrowers(per 1000 adults) in Brazil and Borrowers(per 1000 adults) in Congo (Democratic)?
Your response must be concise. 151.06. In the year 2010, what is the difference between the Borrowers(per 1000 adults) of Europe(developing only) and Borrowers(per 1000 adults) of Lower middle income?
Offer a very short reply. 86.64. In the year 2010, what is the difference between the Borrowers(per 1000 adults) in Europe(developing only) and Borrowers(per 1000 adults) in Brazil?
Give a very brief answer. -80.11. In the year 2010, what is the difference between the Borrowers(per 1000 adults) of Europe(developing only) and Borrowers(per 1000 adults) of Congo (Democratic)?
Make the answer very short. 125.74. In the year 2010, what is the difference between the Borrowers(per 1000 adults) in Lower middle income and Borrowers(per 1000 adults) in Brazil?
Give a very brief answer. -166.74. In the year 2010, what is the difference between the Borrowers(per 1000 adults) of Lower middle income and Borrowers(per 1000 adults) of Congo (Democratic)?
Your response must be concise. 39.11. In the year 2010, what is the difference between the Borrowers(per 1000 adults) in Brazil and Borrowers(per 1000 adults) in Congo (Democratic)?
Provide a short and direct response. 205.85. In the year 2011, what is the difference between the Borrowers(per 1000 adults) of Europe(developing only) and Borrowers(per 1000 adults) of Lower middle income?
Offer a terse response. 82.58. In the year 2011, what is the difference between the Borrowers(per 1000 adults) of Europe(developing only) and Borrowers(per 1000 adults) of Brazil?
Your answer should be compact. -98.3. In the year 2011, what is the difference between the Borrowers(per 1000 adults) in Europe(developing only) and Borrowers(per 1000 adults) in Congo (Democratic)?
Ensure brevity in your answer.  137.77. In the year 2011, what is the difference between the Borrowers(per 1000 adults) in Lower middle income and Borrowers(per 1000 adults) in Brazil?
Give a very brief answer. -180.88. In the year 2011, what is the difference between the Borrowers(per 1000 adults) in Lower middle income and Borrowers(per 1000 adults) in Congo (Democratic)?
Offer a terse response. 55.18. In the year 2011, what is the difference between the Borrowers(per 1000 adults) in Brazil and Borrowers(per 1000 adults) in Congo (Democratic)?
Make the answer very short. 236.07. In the year 2012, what is the difference between the Borrowers(per 1000 adults) of Europe(developing only) and Borrowers(per 1000 adults) of Lower middle income?
Offer a very short reply. 104.7. In the year 2012, what is the difference between the Borrowers(per 1000 adults) of Europe(developing only) and Borrowers(per 1000 adults) of Brazil?
Offer a very short reply. -221.81. In the year 2012, what is the difference between the Borrowers(per 1000 adults) in Europe(developing only) and Borrowers(per 1000 adults) in Congo (Democratic)?
Ensure brevity in your answer.  149.21. In the year 2012, what is the difference between the Borrowers(per 1000 adults) in Lower middle income and Borrowers(per 1000 adults) in Brazil?
Make the answer very short. -326.52. In the year 2012, what is the difference between the Borrowers(per 1000 adults) of Lower middle income and Borrowers(per 1000 adults) of Congo (Democratic)?
Offer a terse response. 44.51. In the year 2012, what is the difference between the Borrowers(per 1000 adults) of Brazil and Borrowers(per 1000 adults) of Congo (Democratic)?
Make the answer very short. 371.02. In the year 2013, what is the difference between the Borrowers(per 1000 adults) in Europe(developing only) and Borrowers(per 1000 adults) in Lower middle income?
Your answer should be very brief. 174.37. In the year 2013, what is the difference between the Borrowers(per 1000 adults) in Europe(developing only) and Borrowers(per 1000 adults) in Brazil?
Your answer should be compact. -178.58. In the year 2013, what is the difference between the Borrowers(per 1000 adults) in Europe(developing only) and Borrowers(per 1000 adults) in Congo (Democratic)?
Give a very brief answer. 217.2. In the year 2013, what is the difference between the Borrowers(per 1000 adults) in Lower middle income and Borrowers(per 1000 adults) in Brazil?
Give a very brief answer. -352.95. In the year 2013, what is the difference between the Borrowers(per 1000 adults) of Lower middle income and Borrowers(per 1000 adults) of Congo (Democratic)?
Provide a succinct answer. 42.83. In the year 2013, what is the difference between the Borrowers(per 1000 adults) in Brazil and Borrowers(per 1000 adults) in Congo (Democratic)?
Keep it short and to the point. 395.78. In the year 2014, what is the difference between the Borrowers(per 1000 adults) of Europe(developing only) and Borrowers(per 1000 adults) of Lower middle income?
Your answer should be very brief. 161.15. In the year 2014, what is the difference between the Borrowers(per 1000 adults) of Europe(developing only) and Borrowers(per 1000 adults) of Brazil?
Provide a short and direct response. -164.8. In the year 2014, what is the difference between the Borrowers(per 1000 adults) in Europe(developing only) and Borrowers(per 1000 adults) in Congo (Democratic)?
Your answer should be compact. 235.32. In the year 2014, what is the difference between the Borrowers(per 1000 adults) of Lower middle income and Borrowers(per 1000 adults) of Brazil?
Your response must be concise. -325.95. In the year 2014, what is the difference between the Borrowers(per 1000 adults) of Lower middle income and Borrowers(per 1000 adults) of Congo (Democratic)?
Your answer should be very brief. 74.17. In the year 2014, what is the difference between the Borrowers(per 1000 adults) of Brazil and Borrowers(per 1000 adults) of Congo (Democratic)?
Provide a short and direct response. 400.12. What is the ratio of the Borrowers(per 1000 adults) of Europe(developing only) in 2008 to that in 2009?
Provide a succinct answer. 1.31. What is the ratio of the Borrowers(per 1000 adults) in Lower middle income in 2008 to that in 2009?
Your response must be concise. 1.46. What is the ratio of the Borrowers(per 1000 adults) in Brazil in 2008 to that in 2009?
Your response must be concise. 0.7. What is the ratio of the Borrowers(per 1000 adults) in Congo (Democratic) in 2008 to that in 2009?
Make the answer very short. 0.76. What is the ratio of the Borrowers(per 1000 adults) in Europe(developing only) in 2008 to that in 2010?
Make the answer very short. 1.09. What is the ratio of the Borrowers(per 1000 adults) of Lower middle income in 2008 to that in 2010?
Give a very brief answer. 1.57. What is the ratio of the Borrowers(per 1000 adults) of Brazil in 2008 to that in 2010?
Ensure brevity in your answer.  0.51. What is the ratio of the Borrowers(per 1000 adults) of Congo (Democratic) in 2008 to that in 2010?
Offer a very short reply. 0.46. What is the ratio of the Borrowers(per 1000 adults) of Europe(developing only) in 2008 to that in 2011?
Keep it short and to the point. 1. What is the ratio of the Borrowers(per 1000 adults) in Lower middle income in 2008 to that in 2011?
Keep it short and to the point. 1.12. What is the ratio of the Borrowers(per 1000 adults) of Brazil in 2008 to that in 2011?
Your response must be concise. 0.45. What is the ratio of the Borrowers(per 1000 adults) in Congo (Democratic) in 2008 to that in 2011?
Provide a short and direct response. 0.35. What is the ratio of the Borrowers(per 1000 adults) of Europe(developing only) in 2008 to that in 2012?
Offer a very short reply. 0.91. What is the ratio of the Borrowers(per 1000 adults) of Lower middle income in 2008 to that in 2012?
Your response must be concise. 1.32. What is the ratio of the Borrowers(per 1000 adults) in Brazil in 2008 to that in 2012?
Your answer should be very brief. 0.28. What is the ratio of the Borrowers(per 1000 adults) in Congo (Democratic) in 2008 to that in 2012?
Offer a very short reply. 0.15. What is the ratio of the Borrowers(per 1000 adults) of Europe(developing only) in 2008 to that in 2013?
Keep it short and to the point. 0.63. What is the ratio of the Borrowers(per 1000 adults) in Lower middle income in 2008 to that in 2013?
Ensure brevity in your answer.  1.37. What is the ratio of the Borrowers(per 1000 adults) of Brazil in 2008 to that in 2013?
Your answer should be compact. 0.27. What is the ratio of the Borrowers(per 1000 adults) of Congo (Democratic) in 2008 to that in 2013?
Ensure brevity in your answer.  0.15. What is the ratio of the Borrowers(per 1000 adults) of Europe(developing only) in 2008 to that in 2014?
Provide a short and direct response. 0.58. What is the ratio of the Borrowers(per 1000 adults) of Lower middle income in 2008 to that in 2014?
Offer a very short reply. 0.8. What is the ratio of the Borrowers(per 1000 adults) of Brazil in 2008 to that in 2014?
Your answer should be very brief. 0.26. What is the ratio of the Borrowers(per 1000 adults) in Congo (Democratic) in 2008 to that in 2014?
Your answer should be very brief. 0.11. What is the ratio of the Borrowers(per 1000 adults) of Europe(developing only) in 2009 to that in 2010?
Offer a terse response. 0.84. What is the ratio of the Borrowers(per 1000 adults) in Lower middle income in 2009 to that in 2010?
Offer a terse response. 1.08. What is the ratio of the Borrowers(per 1000 adults) of Brazil in 2009 to that in 2010?
Offer a very short reply. 0.73. What is the ratio of the Borrowers(per 1000 adults) in Congo (Democratic) in 2009 to that in 2010?
Your answer should be compact. 0.61. What is the ratio of the Borrowers(per 1000 adults) of Europe(developing only) in 2009 to that in 2011?
Provide a succinct answer. 0.76. What is the ratio of the Borrowers(per 1000 adults) in Lower middle income in 2009 to that in 2011?
Make the answer very short. 0.77. What is the ratio of the Borrowers(per 1000 adults) of Brazil in 2009 to that in 2011?
Give a very brief answer. 0.64. What is the ratio of the Borrowers(per 1000 adults) of Congo (Democratic) in 2009 to that in 2011?
Provide a short and direct response. 0.46. What is the ratio of the Borrowers(per 1000 adults) in Europe(developing only) in 2009 to that in 2012?
Make the answer very short. 0.69. What is the ratio of the Borrowers(per 1000 adults) of Lower middle income in 2009 to that in 2012?
Make the answer very short. 0.9. What is the ratio of the Borrowers(per 1000 adults) of Brazil in 2009 to that in 2012?
Your answer should be compact. 0.41. What is the ratio of the Borrowers(per 1000 adults) in Congo (Democratic) in 2009 to that in 2012?
Give a very brief answer. 0.19. What is the ratio of the Borrowers(per 1000 adults) in Europe(developing only) in 2009 to that in 2013?
Your response must be concise. 0.48. What is the ratio of the Borrowers(per 1000 adults) in Lower middle income in 2009 to that in 2013?
Offer a very short reply. 0.94. What is the ratio of the Borrowers(per 1000 adults) of Brazil in 2009 to that in 2013?
Your answer should be compact. 0.38. What is the ratio of the Borrowers(per 1000 adults) in Congo (Democratic) in 2009 to that in 2013?
Your answer should be compact. 0.2. What is the ratio of the Borrowers(per 1000 adults) of Europe(developing only) in 2009 to that in 2014?
Provide a short and direct response. 0.44. What is the ratio of the Borrowers(per 1000 adults) of Lower middle income in 2009 to that in 2014?
Your answer should be compact. 0.55. What is the ratio of the Borrowers(per 1000 adults) in Brazil in 2009 to that in 2014?
Your answer should be very brief. 0.37. What is the ratio of the Borrowers(per 1000 adults) in Congo (Democratic) in 2009 to that in 2014?
Make the answer very short. 0.14. What is the ratio of the Borrowers(per 1000 adults) in Europe(developing only) in 2010 to that in 2011?
Your answer should be compact. 0.91. What is the ratio of the Borrowers(per 1000 adults) of Lower middle income in 2010 to that in 2011?
Ensure brevity in your answer.  0.71. What is the ratio of the Borrowers(per 1000 adults) in Brazil in 2010 to that in 2011?
Offer a terse response. 0.87. What is the ratio of the Borrowers(per 1000 adults) of Congo (Democratic) in 2010 to that in 2011?
Your response must be concise. 0.75. What is the ratio of the Borrowers(per 1000 adults) in Europe(developing only) in 2010 to that in 2012?
Keep it short and to the point. 0.83. What is the ratio of the Borrowers(per 1000 adults) of Lower middle income in 2010 to that in 2012?
Ensure brevity in your answer.  0.84. What is the ratio of the Borrowers(per 1000 adults) in Brazil in 2010 to that in 2012?
Give a very brief answer. 0.55. What is the ratio of the Borrowers(per 1000 adults) in Congo (Democratic) in 2010 to that in 2012?
Your answer should be compact. 0.32. What is the ratio of the Borrowers(per 1000 adults) in Europe(developing only) in 2010 to that in 2013?
Provide a short and direct response. 0.58. What is the ratio of the Borrowers(per 1000 adults) in Lower middle income in 2010 to that in 2013?
Make the answer very short. 0.87. What is the ratio of the Borrowers(per 1000 adults) of Brazil in 2010 to that in 2013?
Provide a short and direct response. 0.52. What is the ratio of the Borrowers(per 1000 adults) in Congo (Democratic) in 2010 to that in 2013?
Make the answer very short. 0.33. What is the ratio of the Borrowers(per 1000 adults) of Europe(developing only) in 2010 to that in 2014?
Your answer should be compact. 0.53. What is the ratio of the Borrowers(per 1000 adults) of Lower middle income in 2010 to that in 2014?
Your answer should be very brief. 0.51. What is the ratio of the Borrowers(per 1000 adults) of Brazil in 2010 to that in 2014?
Keep it short and to the point. 0.51. What is the ratio of the Borrowers(per 1000 adults) of Congo (Democratic) in 2010 to that in 2014?
Your response must be concise. 0.23. What is the ratio of the Borrowers(per 1000 adults) of Europe(developing only) in 2011 to that in 2012?
Your response must be concise. 0.91. What is the ratio of the Borrowers(per 1000 adults) of Lower middle income in 2011 to that in 2012?
Offer a terse response. 1.18. What is the ratio of the Borrowers(per 1000 adults) in Brazil in 2011 to that in 2012?
Your answer should be compact. 0.63. What is the ratio of the Borrowers(per 1000 adults) in Congo (Democratic) in 2011 to that in 2012?
Offer a very short reply. 0.42. What is the ratio of the Borrowers(per 1000 adults) of Europe(developing only) in 2011 to that in 2013?
Give a very brief answer. 0.63. What is the ratio of the Borrowers(per 1000 adults) in Lower middle income in 2011 to that in 2013?
Ensure brevity in your answer.  1.23. What is the ratio of the Borrowers(per 1000 adults) of Brazil in 2011 to that in 2013?
Your response must be concise. 0.6. What is the ratio of the Borrowers(per 1000 adults) in Congo (Democratic) in 2011 to that in 2013?
Make the answer very short. 0.45. What is the ratio of the Borrowers(per 1000 adults) of Europe(developing only) in 2011 to that in 2014?
Make the answer very short. 0.58. What is the ratio of the Borrowers(per 1000 adults) in Lower middle income in 2011 to that in 2014?
Make the answer very short. 0.72. What is the ratio of the Borrowers(per 1000 adults) in Brazil in 2011 to that in 2014?
Ensure brevity in your answer.  0.59. What is the ratio of the Borrowers(per 1000 adults) of Congo (Democratic) in 2011 to that in 2014?
Keep it short and to the point. 0.31. What is the ratio of the Borrowers(per 1000 adults) of Europe(developing only) in 2012 to that in 2013?
Provide a short and direct response. 0.69. What is the ratio of the Borrowers(per 1000 adults) of Lower middle income in 2012 to that in 2013?
Keep it short and to the point. 1.04. What is the ratio of the Borrowers(per 1000 adults) of Brazil in 2012 to that in 2013?
Provide a short and direct response. 0.94. What is the ratio of the Borrowers(per 1000 adults) in Congo (Democratic) in 2012 to that in 2013?
Your response must be concise. 1.06. What is the ratio of the Borrowers(per 1000 adults) of Europe(developing only) in 2012 to that in 2014?
Your answer should be very brief. 0.64. What is the ratio of the Borrowers(per 1000 adults) in Lower middle income in 2012 to that in 2014?
Make the answer very short. 0.61. What is the ratio of the Borrowers(per 1000 adults) of Brazil in 2012 to that in 2014?
Offer a terse response. 0.92. What is the ratio of the Borrowers(per 1000 adults) of Congo (Democratic) in 2012 to that in 2014?
Provide a short and direct response. 0.73. What is the ratio of the Borrowers(per 1000 adults) in Europe(developing only) in 2013 to that in 2014?
Your answer should be very brief. 0.92. What is the ratio of the Borrowers(per 1000 adults) in Lower middle income in 2013 to that in 2014?
Offer a very short reply. 0.58. What is the ratio of the Borrowers(per 1000 adults) of Brazil in 2013 to that in 2014?
Give a very brief answer. 0.99. What is the ratio of the Borrowers(per 1000 adults) in Congo (Democratic) in 2013 to that in 2014?
Your response must be concise. 0.68. What is the difference between the highest and the second highest Borrowers(per 1000 adults) in Europe(developing only)?
Keep it short and to the point. 19.67. What is the difference between the highest and the second highest Borrowers(per 1000 adults) in Lower middle income?
Your response must be concise. 15.72. What is the difference between the highest and the second highest Borrowers(per 1000 adults) in Brazil?
Make the answer very short. 5.89. What is the difference between the highest and the second highest Borrowers(per 1000 adults) of Congo (Democratic)?
Provide a succinct answer. 1.34. What is the difference between the highest and the lowest Borrowers(per 1000 adults) in Europe(developing only)?
Offer a very short reply. 134.19. What is the difference between the highest and the lowest Borrowers(per 1000 adults) of Lower middle income?
Provide a short and direct response. 38.85. What is the difference between the highest and the lowest Borrowers(per 1000 adults) in Brazil?
Keep it short and to the point. 299.25. What is the difference between the highest and the lowest Borrowers(per 1000 adults) in Congo (Democratic)?
Offer a terse response. 4.39. 